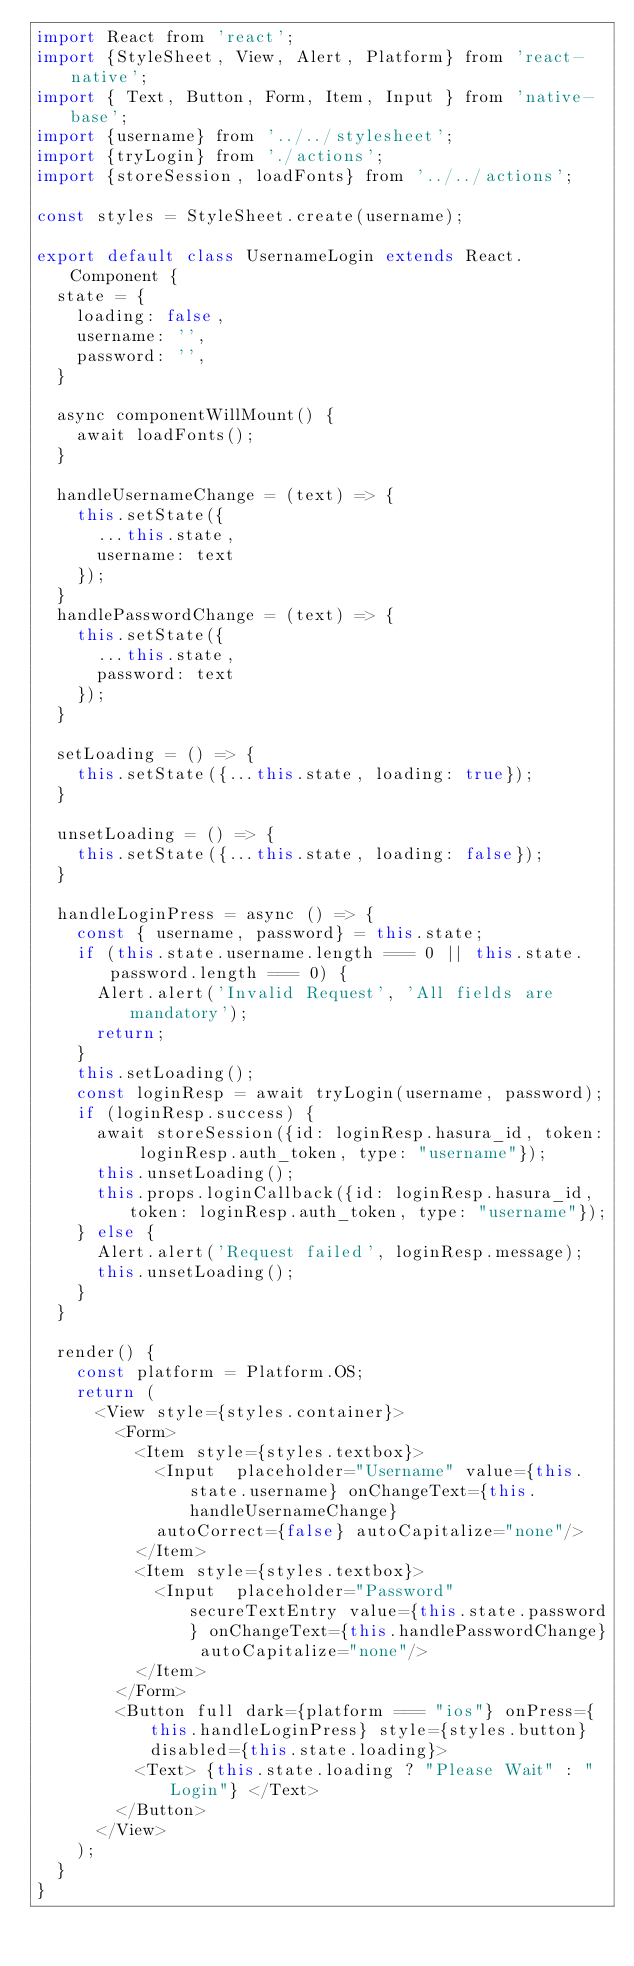Convert code to text. <code><loc_0><loc_0><loc_500><loc_500><_JavaScript_>import React from 'react';
import {StyleSheet, View, Alert, Platform} from 'react-native';
import { Text, Button, Form, Item, Input } from 'native-base';
import {username} from '../../stylesheet';
import {tryLogin} from './actions';
import {storeSession, loadFonts} from '../../actions';

const styles = StyleSheet.create(username);

export default class UsernameLogin extends React.Component {
  state = {
    loading: false,
    username: '',
    password: '',
  }

  async componentWillMount() {
    await loadFonts();
  }

  handleUsernameChange = (text) => {
    this.setState({
      ...this.state,
      username: text
    });
  }
  handlePasswordChange = (text) => {
    this.setState({
      ...this.state,
      password: text
    });
  }

  setLoading = () => {
    this.setState({...this.state, loading: true});
  }

  unsetLoading = () => {
    this.setState({...this.state, loading: false});
  }

  handleLoginPress = async () => {
    const { username, password} = this.state;
    if (this.state.username.length === 0 || this.state.password.length === 0) {
      Alert.alert('Invalid Request', 'All fields are mandatory');
      return;
    }
    this.setLoading();
    const loginResp = await tryLogin(username, password);
    if (loginResp.success) {
      await storeSession({id: loginResp.hasura_id, token: loginResp.auth_token, type: "username"});
      this.unsetLoading();
      this.props.loginCallback({id: loginResp.hasura_id, token: loginResp.auth_token, type: "username"});
    } else {
      Alert.alert('Request failed', loginResp.message);
      this.unsetLoading();
    }
  }

  render() {
    const platform = Platform.OS;
    return (
      <View style={styles.container}>
        <Form>
          <Item style={styles.textbox}>
            <Input  placeholder="Username" value={this.state.username} onChangeText={this.handleUsernameChange}
            autoCorrect={false} autoCapitalize="none"/>
          </Item>
          <Item style={styles.textbox}>
            <Input  placeholder="Password" secureTextEntry value={this.state.password} onChangeText={this.handlePasswordChange} autoCapitalize="none"/>
          </Item>
        </Form>
        <Button full dark={platform === "ios"} onPress={this.handleLoginPress} style={styles.button} disabled={this.state.loading}>
          <Text> {this.state.loading ? "Please Wait" : "Login"} </Text>
        </Button>
      </View>
    );
  }
}
</code> 